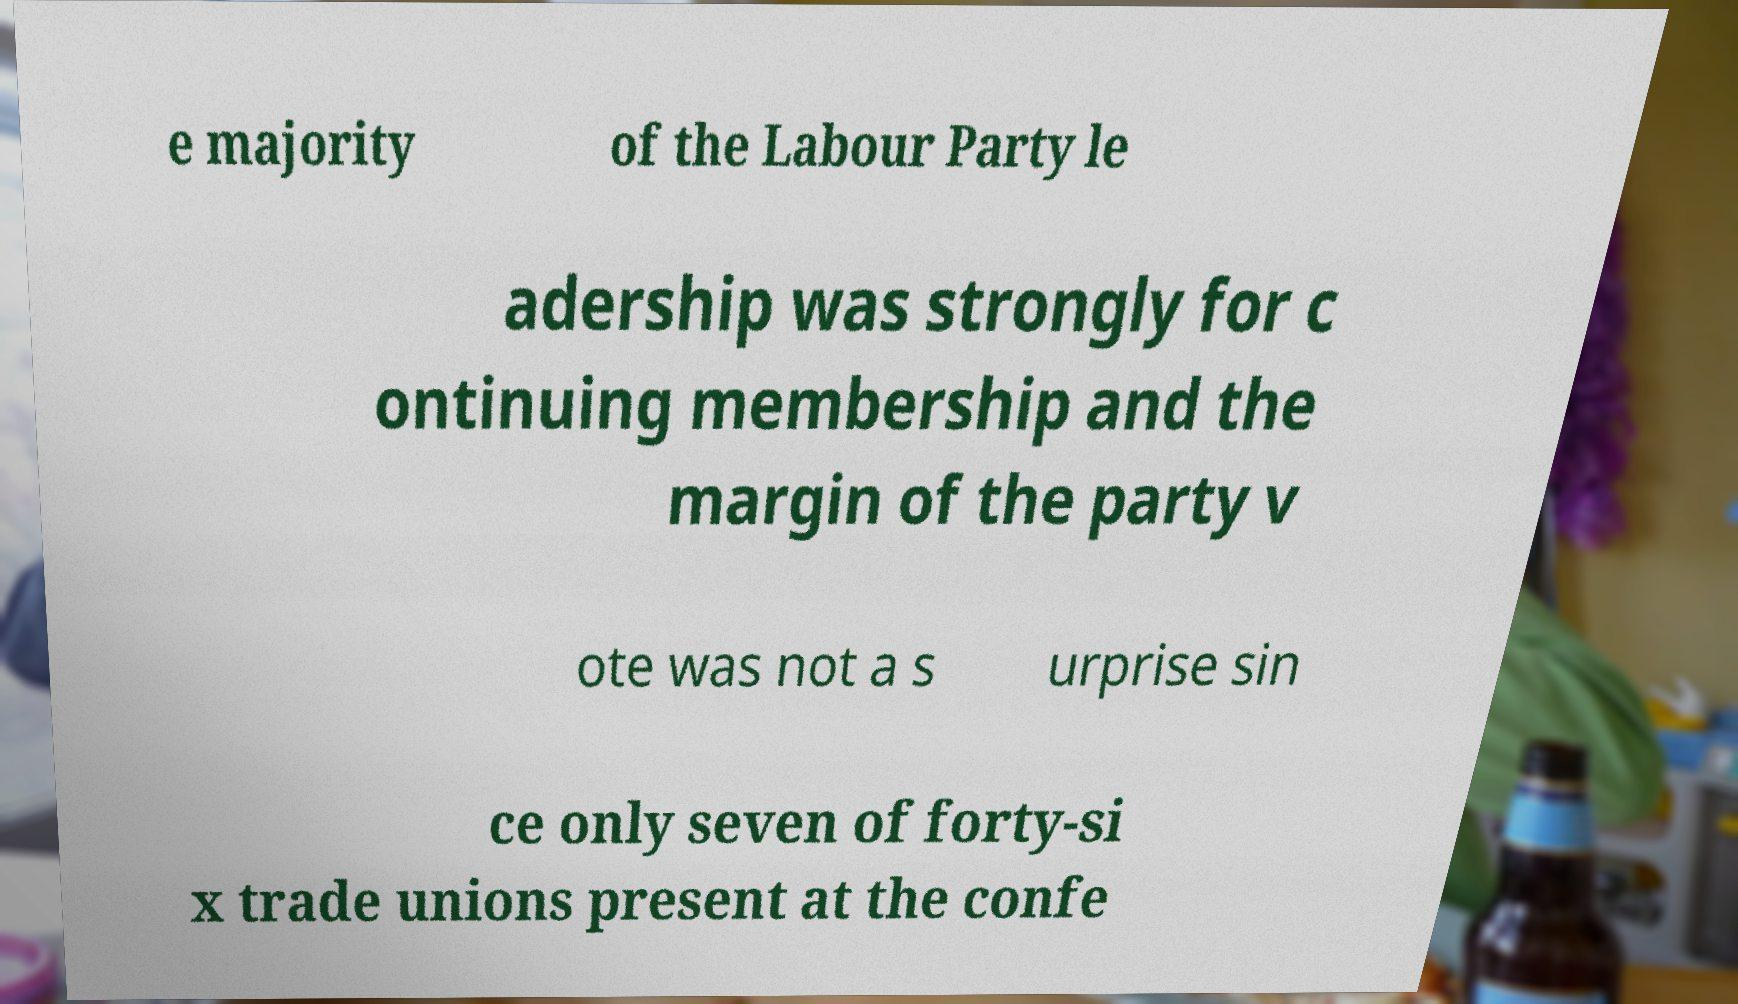What messages or text are displayed in this image? I need them in a readable, typed format. e majority of the Labour Party le adership was strongly for c ontinuing membership and the margin of the party v ote was not a s urprise sin ce only seven of forty-si x trade unions present at the confe 